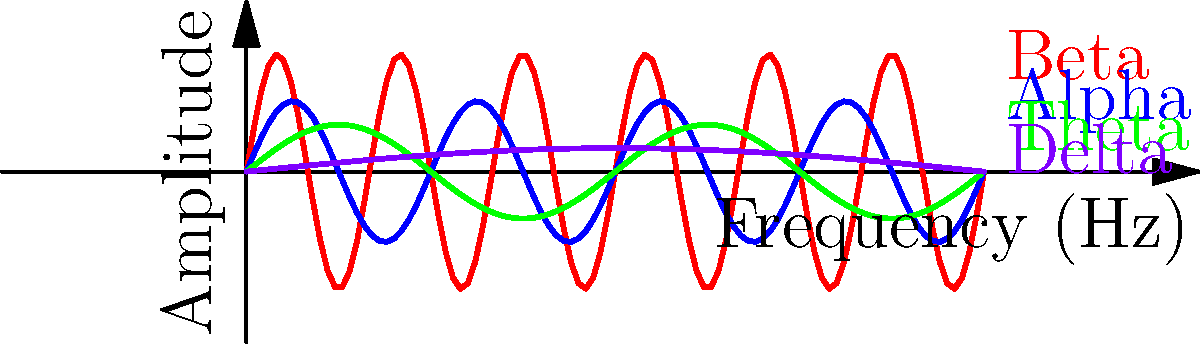Match the EEG wave patterns shown in the graph to their corresponding states of consciousness:

1. Beta waves
2. Alpha waves
3. Theta waves
4. Delta waves

A) Deep sleep
B) Relaxed wakefulness
C) Drowsiness or light sleep
D) Alert, focused attention To match EEG wave patterns to states of consciousness, we need to understand the characteristics of each wave type and their associated mental states:

1. Beta waves (red):
   - Highest frequency (12-30 Hz) and lowest amplitude
   - Associated with alert, focused attention and active problem-solving
   - Correct match: D) Alert, focused attention

2. Alpha waves (blue):
   - Moderate frequency (8-13 Hz) and amplitude
   - Associated with relaxed wakefulness, closed eyes, and meditation
   - Correct match: B) Relaxed wakefulness

3. Theta waves (green):
   - Lower frequency (4-8 Hz) and higher amplitude
   - Associated with drowsiness, light sleep, and deep meditation
   - Correct match: C) Drowsiness or light sleep

4. Delta waves (purple):
   - Lowest frequency (0.5-4 Hz) and highest amplitude
   - Associated with deep, dreamless sleep and unconsciousness
   - Correct match: A) Deep sleep

The graph clearly shows the decreasing frequency and increasing amplitude as we move from Beta to Delta waves, which corresponds to the progression from high alertness to deep sleep.
Answer: 1-D, 2-B, 3-C, 4-A 